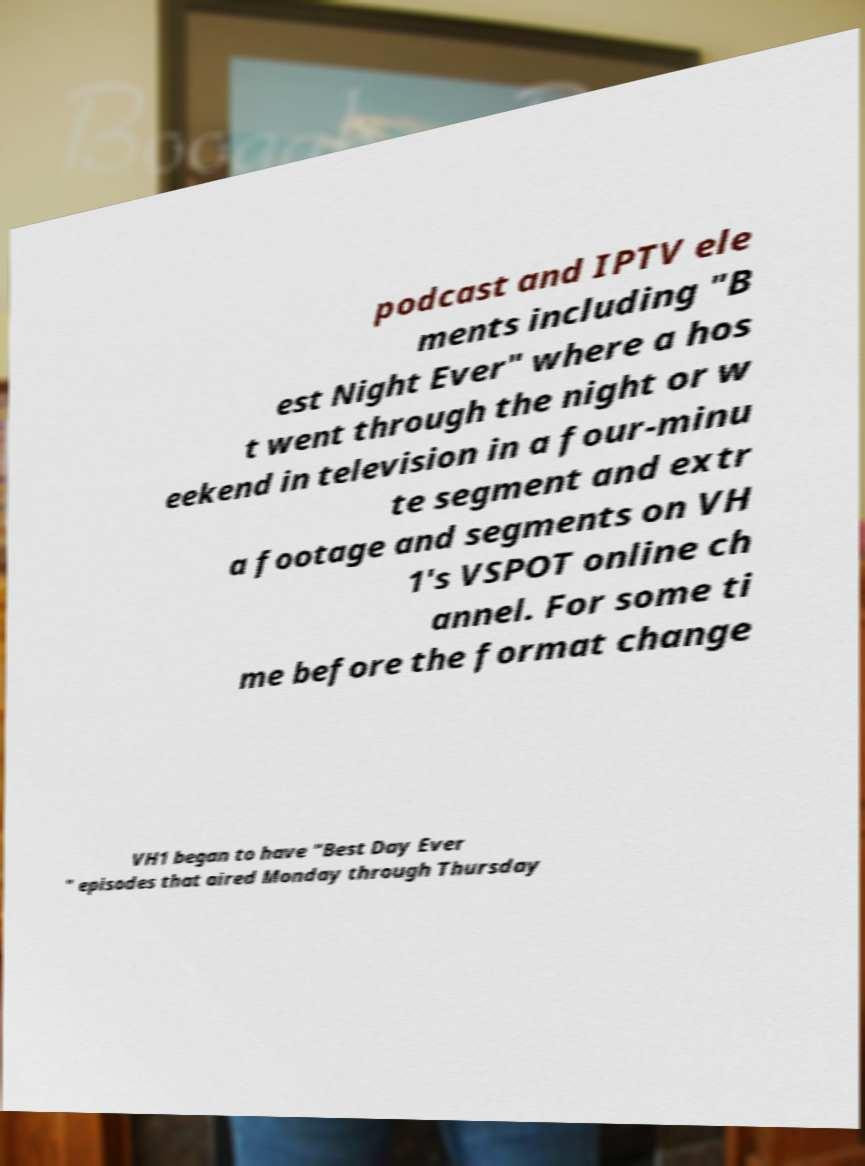Can you accurately transcribe the text from the provided image for me? podcast and IPTV ele ments including "B est Night Ever" where a hos t went through the night or w eekend in television in a four-minu te segment and extr a footage and segments on VH 1's VSPOT online ch annel. For some ti me before the format change VH1 began to have "Best Day Ever " episodes that aired Monday through Thursday 